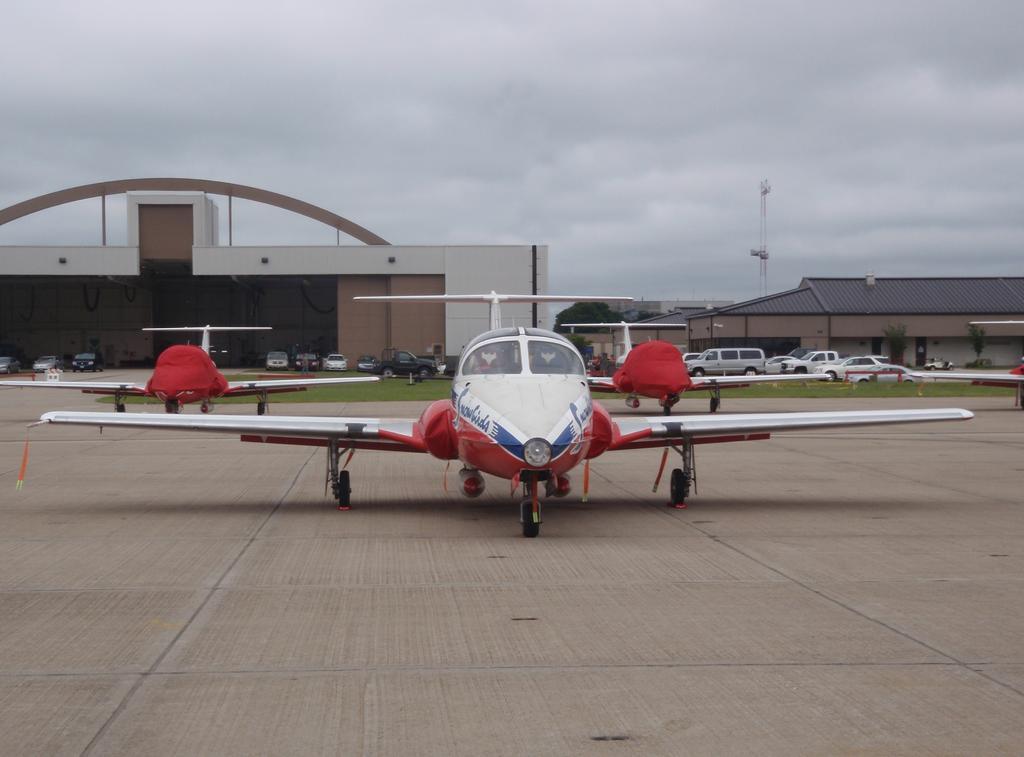Describe this image in one or two sentences. There are aircraft in the foreground area of the image, there are vehicles, grassland, sheds, trees, tower and the sky in the background. 